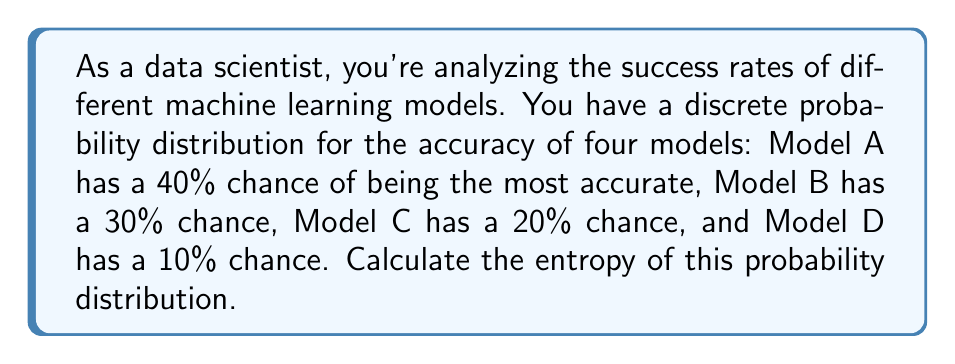Provide a solution to this math problem. To calculate the entropy of a discrete probability distribution, we use the formula:

$$H = -\sum_{i=1}^{n} p_i \log_2(p_i)$$

Where:
- $H$ is the entropy
- $p_i$ is the probability of each event
- $n$ is the number of possible events

Let's calculate step by step:

1) We have four probabilities:
   $p_1 = 0.4$ (Model A)
   $p_2 = 0.3$ (Model B)
   $p_3 = 0.2$ (Model C)
   $p_4 = 0.1$ (Model D)

2) Now, let's calculate each term of the sum:

   For $p_1$: $-0.4 \log_2(0.4) \approx 0.5288$
   For $p_2$: $-0.3 \log_2(0.3) \approx 0.5211$
   For $p_3$: $-0.2 \log_2(0.2) \approx 0.4644$
   For $p_4$: $-0.1 \log_2(0.1) \approx 0.3322$

3) Sum all these terms:

   $H = 0.5288 + 0.5211 + 0.4644 + 0.3322 = 1.8465$

Therefore, the entropy of this probability distribution is approximately 1.8465 bits.
Answer: $H \approx 1.8465$ bits 